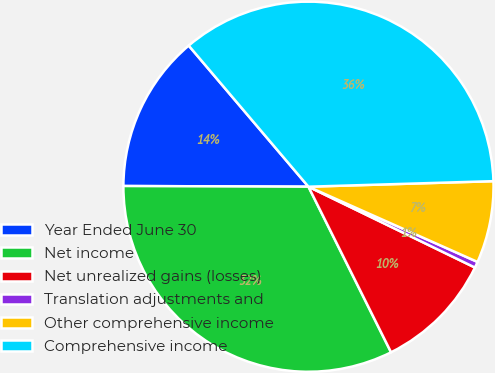<chart> <loc_0><loc_0><loc_500><loc_500><pie_chart><fcel>Year Ended June 30<fcel>Net income<fcel>Net unrealized gains (losses)<fcel>Translation adjustments and<fcel>Other comprehensive income<fcel>Comprehensive income<nl><fcel>13.74%<fcel>32.42%<fcel>10.44%<fcel>0.53%<fcel>7.14%<fcel>35.72%<nl></chart> 